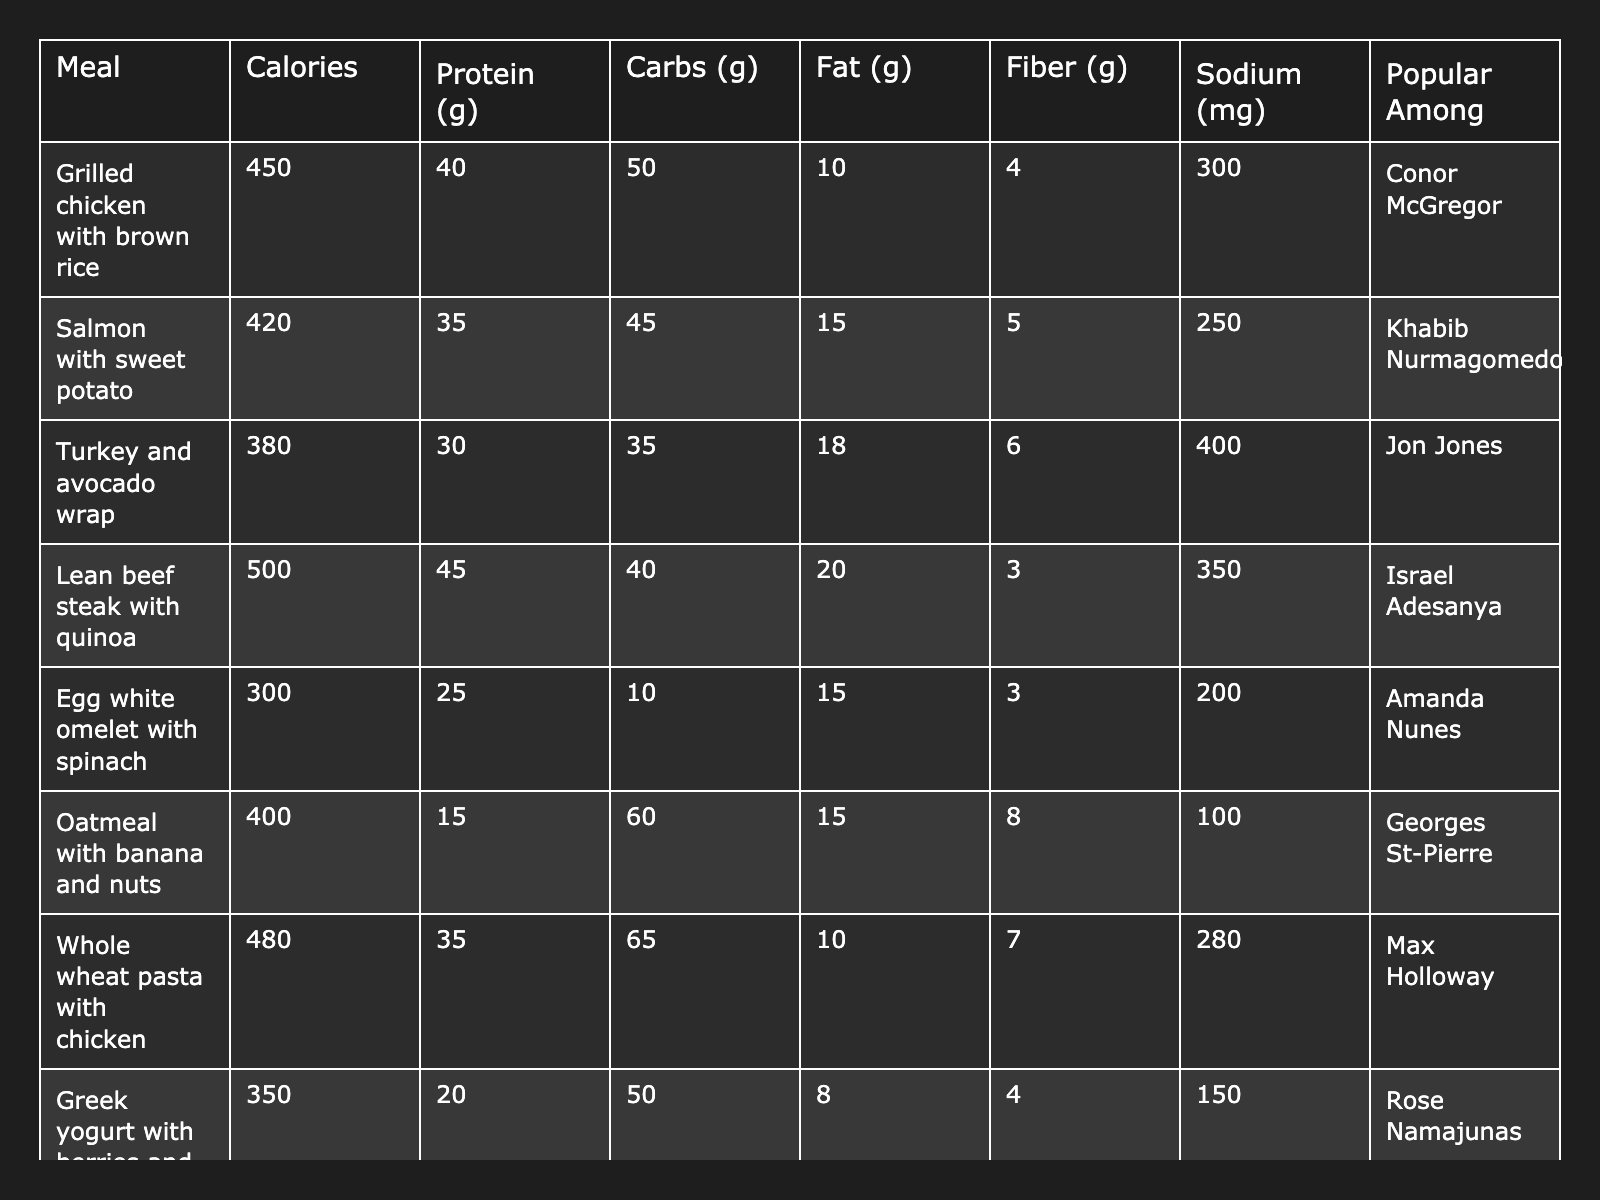What is the highest calorie pre-fight meal listed in the table? By examining the Calories column, the meal with the highest value is "Lean beef steak with quinoa," which has 500 calories.
Answer: 500 calories Which meal is the most popular among MMA fighters according to the table? The table lists individual fighters associated with each meal. "Grilled chicken with brown rice" is linked to Conor McGregor, and this meal appears first. However, to determine the most popular, we conclude that each fighter is associated with a specific meal rather than a rank.
Answer: Each meal is uniquely associated with a fighter How much protein is in the tuna salad with mixed greens? The table indicates that "Tuna salad with mixed greens" has 35 grams of protein in the Protein (g) column.
Answer: 35 grams What is the combined total of carbs for 'Oatmeal with banana and nuts' and 'Greek yogurt with berries and honey'? The carbs for Oatmeal are 60 grams and for Greek yogurt are 50 grams. Adding these, we get 60 + 50 = 110 grams.
Answer: 110 grams Is the sodium content of 'Egg white omelet with spinach' more than 250 mg? The sodium content for "Egg white omelet with spinach" is listed as 200 mg, which is less than 250 mg. Therefore, the answer is no.
Answer: No What is the average fat content of the meals listed in the table? To find the average fat content, we first sum the fat amounts: 10 + 15 + 18 + 20 + 15 + 15 + 10 + 8 + 14 + 12 = 132 grams. There are 10 meals; the average fat content is 132 / 10 = 13.2 grams.
Answer: 13.2 grams Which meal has the lowest fiber content? Looking through the Fiber (g) column, "Lean beef steak with quinoa" has 3 grams, making it the meal with the lowest fiber content listed.
Answer: 3 grams How much sodium does the 'Protein shake with banana and peanut butter' have compared to the 'Salmon with sweet potato'? 'Protein shake with banana and peanut butter' has 200 mg of sodium, while 'Salmon with sweet potato' has 250 mg. This means the protein shake has 50 mg less sodium than the salmon.
Answer: 50 mg less What is the total calorie content of the 'Turkey and avocado wrap' and 'Greek yogurt with berries and honey'? The calorie content for "Turkey and avocado wrap" is 380 calories, and for "Greek yogurt with berries and honey," it is 350 calories. Adding these gives a total of 380 + 350 = 730 calories.
Answer: 730 calories Is 'Salmon with sweet potato' higher in carbs than 'Whole wheat pasta with chicken'? The carbs for 'Salmon with sweet potato' is 45 grams, while 'Whole wheat pasta with chicken' is 65 grams. Since 45 is less than 65, the answer is no.
Answer: No 